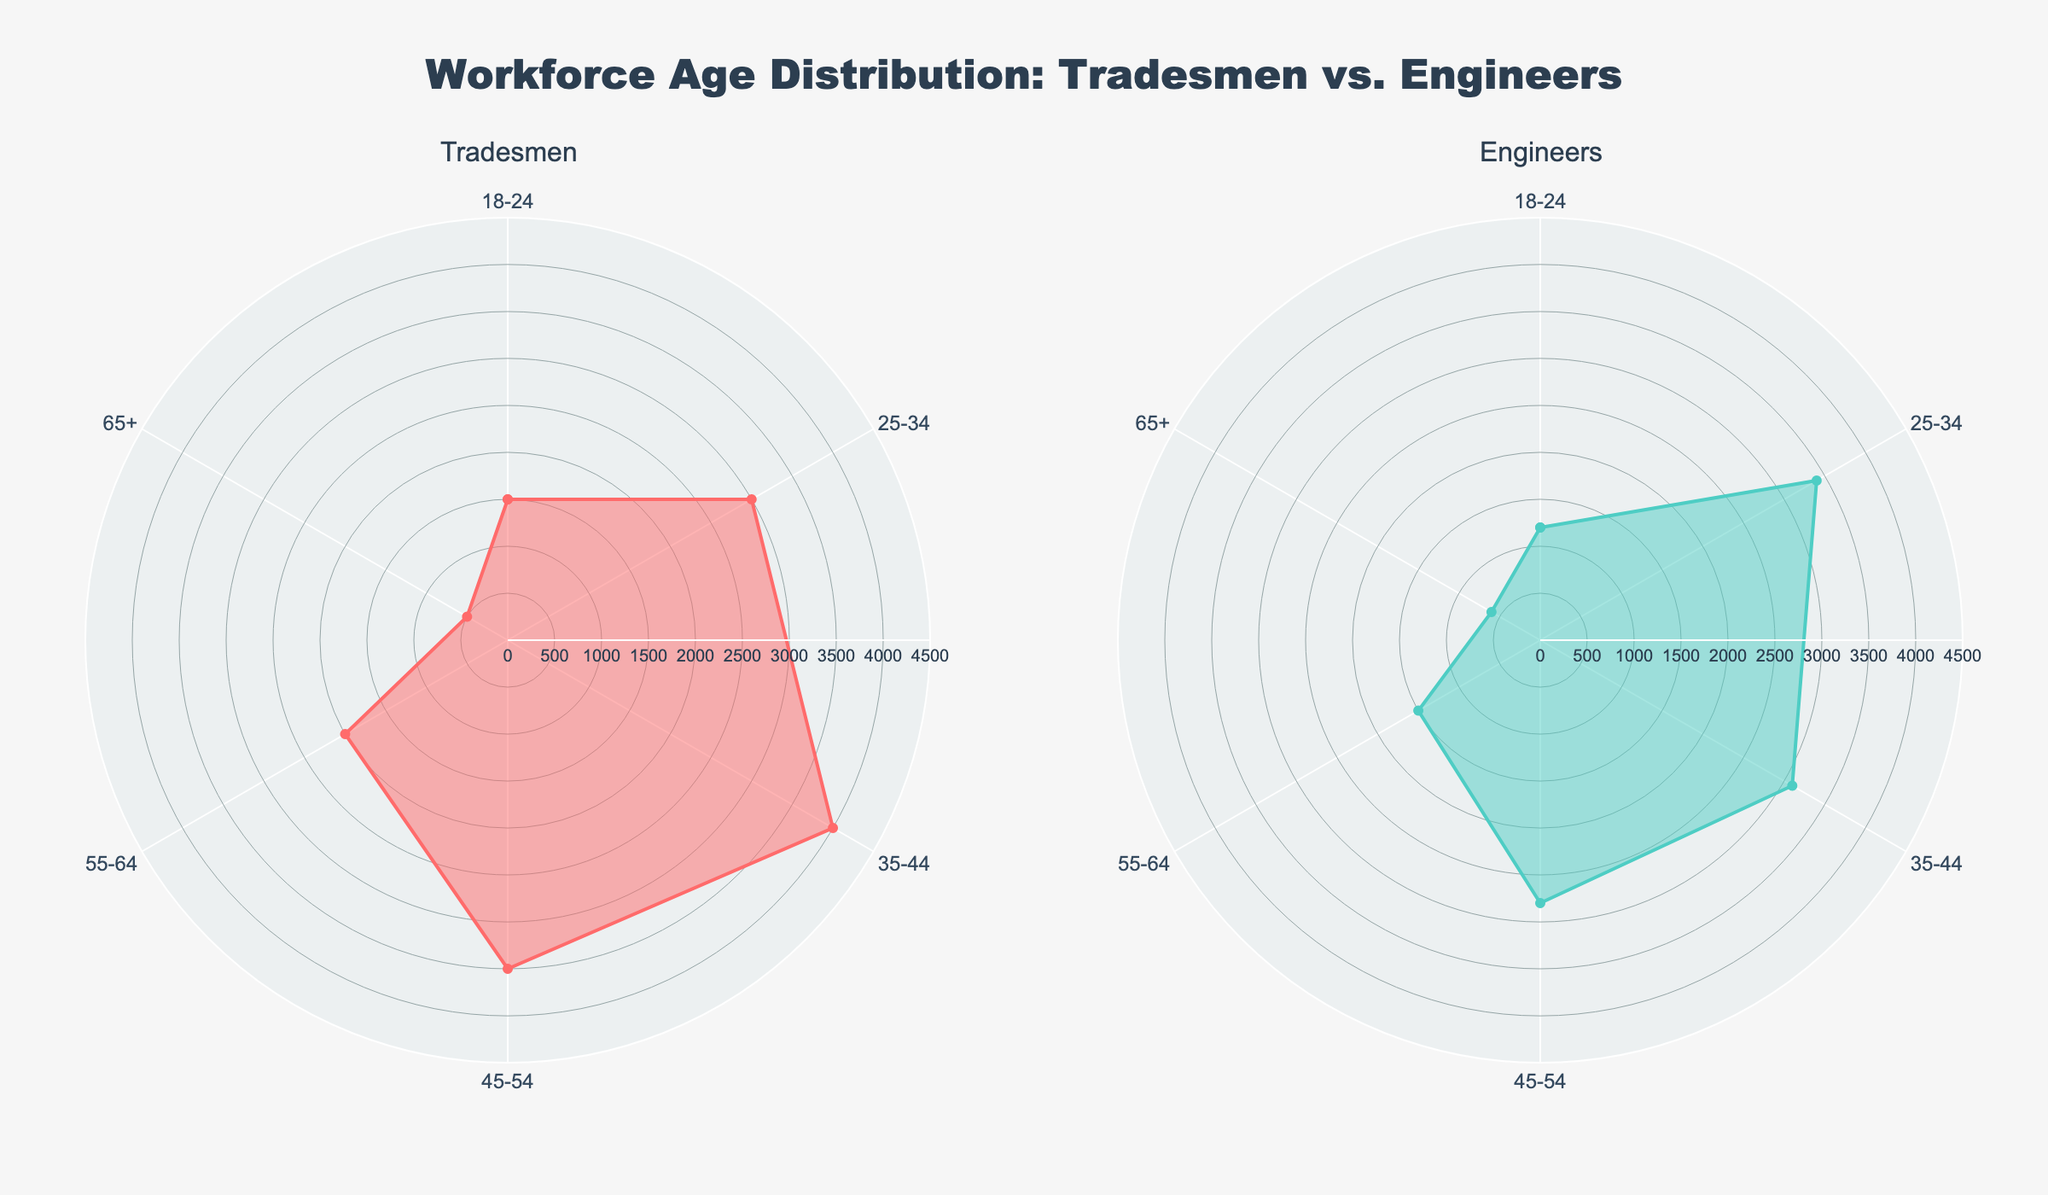What are the titles of the two subplots? The titles of the subplots are written above each radar chart. On the left, the title is "Tradesmen" and on the right, the title is "Engineers".
Answer: "Tradesmen", "Engineers" How many age groups are shown in the chart? The radar chart shows six age groups: 18-24, 25-34, 35-44, 45-54, 55-64, and 65+. This is evident from the categories listed in the radial axis.
Answer: Six Which age group has the highest number of tradesmen? To identify this, observe the red (Tradesmen) radar plot. The age group with the highest value on the y-axis is 35-44.
Answer: 35-44 Which age group has the lowest number of engineers? By examining the green (Engineers) radar plot, the age group with the lowest value is 65+.
Answer: 65+ Compare the number of tradesmen and engineers in the 25-34 age group. In the radar chart, for the 25-34 age group, the number of tradesmen is plotted as 3000 and the number of engineers is plotted as 3400. Comparing these, engineers are higher.
Answer: Engineers What is the ratio of engineers to tradesmen in the 55-64 age group? The number of engineers in the 55-64 age group is 1500, and the number of tradesmen is 2000. The ratio of engineers to tradesmen is calculated as 1500/2000 = 0.75.
Answer: 0.75 Which profession has a more uniform age distribution? To identify this, observe the smoothness and uniformity of the radar plot lines. Engineers (green) have a more uniform distribution compared to tradesmen (red), as tradesmen have more fluctuation.
Answer: Engineers Calculate the total workforce for tradesmen and engineers. Summing up the number of tradesmen (1500 + 3000 + 4000 + 3500 + 2000 + 500) equals 14500. Summing up the number of engineers (1200 + 3400 + 3100 + 2800 + 1500 + 600) equals 12600.
Answer: Tradesmen: 14500, Engineers: 12600 What is the average number of tradesmen across all age groups? Adding the numbers for tradesmen (1500 + 3000 + 4000 + 3500 + 2000 + 500) and dividing by 6, the average is 14500 / 6 = 2416.67.
Answer: 2416.67 